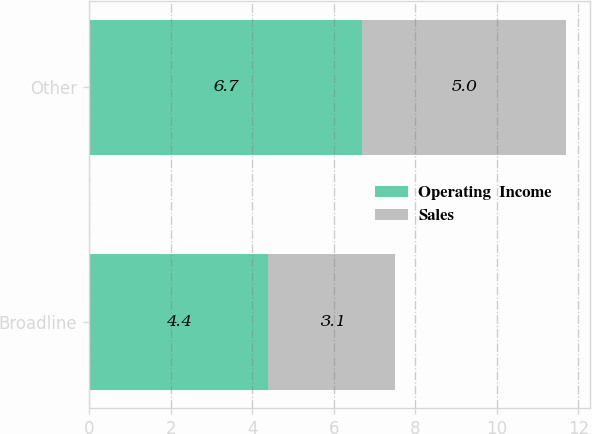Convert chart. <chart><loc_0><loc_0><loc_500><loc_500><stacked_bar_chart><ecel><fcel>Broadline<fcel>Other<nl><fcel>Operating  Income<fcel>4.4<fcel>6.7<nl><fcel>Sales<fcel>3.1<fcel>5<nl></chart> 